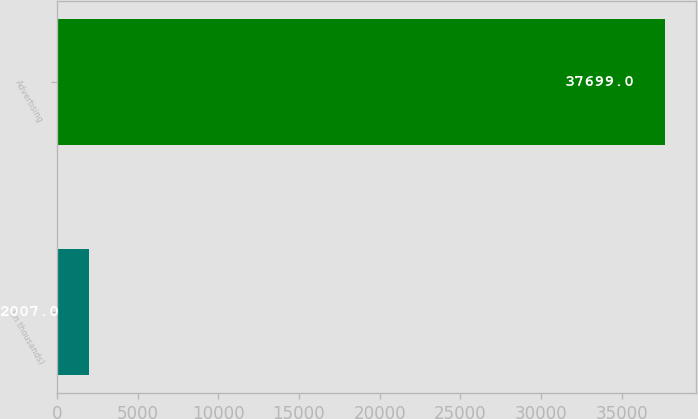Convert chart to OTSL. <chart><loc_0><loc_0><loc_500><loc_500><bar_chart><fcel>(in thousands)<fcel>Advertising<nl><fcel>2007<fcel>37699<nl></chart> 